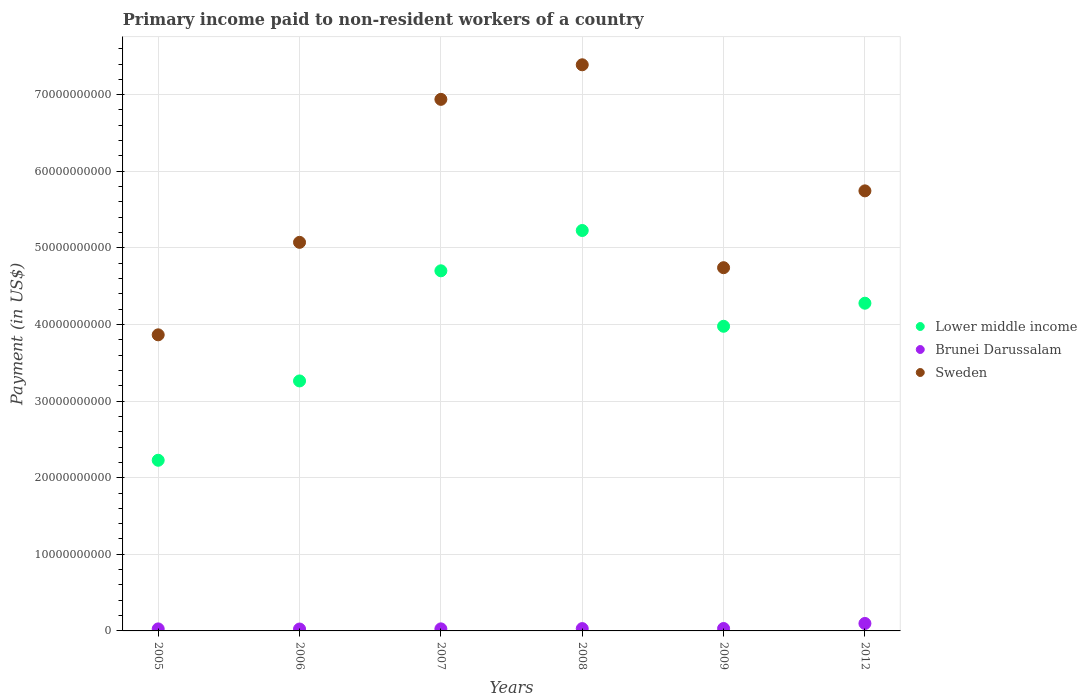How many different coloured dotlines are there?
Ensure brevity in your answer.  3. What is the amount paid to workers in Lower middle income in 2005?
Your response must be concise. 2.23e+1. Across all years, what is the maximum amount paid to workers in Brunei Darussalam?
Provide a short and direct response. 9.74e+08. Across all years, what is the minimum amount paid to workers in Brunei Darussalam?
Make the answer very short. 2.48e+08. What is the total amount paid to workers in Brunei Darussalam in the graph?
Make the answer very short. 2.37e+09. What is the difference between the amount paid to workers in Sweden in 2007 and that in 2012?
Your answer should be compact. 1.19e+1. What is the difference between the amount paid to workers in Brunei Darussalam in 2006 and the amount paid to workers in Lower middle income in 2012?
Give a very brief answer. -4.25e+1. What is the average amount paid to workers in Sweden per year?
Keep it short and to the point. 5.63e+1. In the year 2012, what is the difference between the amount paid to workers in Sweden and amount paid to workers in Brunei Darussalam?
Ensure brevity in your answer.  5.65e+1. In how many years, is the amount paid to workers in Brunei Darussalam greater than 30000000000 US$?
Provide a short and direct response. 0. What is the ratio of the amount paid to workers in Brunei Darussalam in 2007 to that in 2012?
Provide a succinct answer. 0.28. Is the amount paid to workers in Brunei Darussalam in 2005 less than that in 2007?
Provide a short and direct response. Yes. Is the difference between the amount paid to workers in Sweden in 2006 and 2012 greater than the difference between the amount paid to workers in Brunei Darussalam in 2006 and 2012?
Provide a short and direct response. No. What is the difference between the highest and the second highest amount paid to workers in Brunei Darussalam?
Give a very brief answer. 6.58e+08. What is the difference between the highest and the lowest amount paid to workers in Lower middle income?
Keep it short and to the point. 3.00e+1. Is the sum of the amount paid to workers in Brunei Darussalam in 2005 and 2012 greater than the maximum amount paid to workers in Lower middle income across all years?
Give a very brief answer. No. Does the amount paid to workers in Lower middle income monotonically increase over the years?
Provide a succinct answer. No. Is the amount paid to workers in Brunei Darussalam strictly less than the amount paid to workers in Sweden over the years?
Keep it short and to the point. Yes. How many dotlines are there?
Offer a terse response. 3. Does the graph contain any zero values?
Make the answer very short. No. How many legend labels are there?
Offer a very short reply. 3. What is the title of the graph?
Provide a succinct answer. Primary income paid to non-resident workers of a country. Does "Namibia" appear as one of the legend labels in the graph?
Make the answer very short. No. What is the label or title of the Y-axis?
Give a very brief answer. Payment (in US$). What is the Payment (in US$) of Lower middle income in 2005?
Offer a very short reply. 2.23e+1. What is the Payment (in US$) in Brunei Darussalam in 2005?
Offer a very short reply. 2.63e+08. What is the Payment (in US$) in Sweden in 2005?
Keep it short and to the point. 3.87e+1. What is the Payment (in US$) of Lower middle income in 2006?
Ensure brevity in your answer.  3.26e+1. What is the Payment (in US$) in Brunei Darussalam in 2006?
Keep it short and to the point. 2.48e+08. What is the Payment (in US$) of Sweden in 2006?
Offer a very short reply. 5.07e+1. What is the Payment (in US$) of Lower middle income in 2007?
Make the answer very short. 4.70e+1. What is the Payment (in US$) of Brunei Darussalam in 2007?
Provide a short and direct response. 2.68e+08. What is the Payment (in US$) in Sweden in 2007?
Offer a very short reply. 6.94e+1. What is the Payment (in US$) of Lower middle income in 2008?
Your response must be concise. 5.23e+1. What is the Payment (in US$) in Brunei Darussalam in 2008?
Make the answer very short. 3.04e+08. What is the Payment (in US$) in Sweden in 2008?
Keep it short and to the point. 7.39e+1. What is the Payment (in US$) in Lower middle income in 2009?
Keep it short and to the point. 3.98e+1. What is the Payment (in US$) in Brunei Darussalam in 2009?
Keep it short and to the point. 3.16e+08. What is the Payment (in US$) in Sweden in 2009?
Provide a succinct answer. 4.74e+1. What is the Payment (in US$) of Lower middle income in 2012?
Make the answer very short. 4.28e+1. What is the Payment (in US$) in Brunei Darussalam in 2012?
Your answer should be compact. 9.74e+08. What is the Payment (in US$) in Sweden in 2012?
Keep it short and to the point. 5.74e+1. Across all years, what is the maximum Payment (in US$) in Lower middle income?
Give a very brief answer. 5.23e+1. Across all years, what is the maximum Payment (in US$) in Brunei Darussalam?
Provide a short and direct response. 9.74e+08. Across all years, what is the maximum Payment (in US$) of Sweden?
Give a very brief answer. 7.39e+1. Across all years, what is the minimum Payment (in US$) of Lower middle income?
Provide a short and direct response. 2.23e+1. Across all years, what is the minimum Payment (in US$) in Brunei Darussalam?
Your answer should be very brief. 2.48e+08. Across all years, what is the minimum Payment (in US$) of Sweden?
Provide a succinct answer. 3.87e+1. What is the total Payment (in US$) of Lower middle income in the graph?
Ensure brevity in your answer.  2.37e+11. What is the total Payment (in US$) of Brunei Darussalam in the graph?
Ensure brevity in your answer.  2.37e+09. What is the total Payment (in US$) in Sweden in the graph?
Offer a terse response. 3.38e+11. What is the difference between the Payment (in US$) in Lower middle income in 2005 and that in 2006?
Your answer should be compact. -1.04e+1. What is the difference between the Payment (in US$) in Brunei Darussalam in 2005 and that in 2006?
Give a very brief answer. 1.52e+07. What is the difference between the Payment (in US$) in Sweden in 2005 and that in 2006?
Provide a succinct answer. -1.21e+1. What is the difference between the Payment (in US$) in Lower middle income in 2005 and that in 2007?
Your answer should be very brief. -2.47e+1. What is the difference between the Payment (in US$) in Brunei Darussalam in 2005 and that in 2007?
Provide a succinct answer. -5.10e+06. What is the difference between the Payment (in US$) in Sweden in 2005 and that in 2007?
Make the answer very short. -3.07e+1. What is the difference between the Payment (in US$) in Lower middle income in 2005 and that in 2008?
Provide a succinct answer. -3.00e+1. What is the difference between the Payment (in US$) in Brunei Darussalam in 2005 and that in 2008?
Your answer should be compact. -4.04e+07. What is the difference between the Payment (in US$) of Sweden in 2005 and that in 2008?
Offer a very short reply. -3.53e+1. What is the difference between the Payment (in US$) of Lower middle income in 2005 and that in 2009?
Offer a very short reply. -1.75e+1. What is the difference between the Payment (in US$) in Brunei Darussalam in 2005 and that in 2009?
Keep it short and to the point. -5.31e+07. What is the difference between the Payment (in US$) in Sweden in 2005 and that in 2009?
Your response must be concise. -8.76e+09. What is the difference between the Payment (in US$) of Lower middle income in 2005 and that in 2012?
Keep it short and to the point. -2.05e+1. What is the difference between the Payment (in US$) of Brunei Darussalam in 2005 and that in 2012?
Give a very brief answer. -7.11e+08. What is the difference between the Payment (in US$) of Sweden in 2005 and that in 2012?
Your response must be concise. -1.88e+1. What is the difference between the Payment (in US$) in Lower middle income in 2006 and that in 2007?
Your response must be concise. -1.44e+1. What is the difference between the Payment (in US$) in Brunei Darussalam in 2006 and that in 2007?
Your response must be concise. -2.03e+07. What is the difference between the Payment (in US$) of Sweden in 2006 and that in 2007?
Offer a terse response. -1.87e+1. What is the difference between the Payment (in US$) of Lower middle income in 2006 and that in 2008?
Your answer should be compact. -1.96e+1. What is the difference between the Payment (in US$) of Brunei Darussalam in 2006 and that in 2008?
Provide a short and direct response. -5.57e+07. What is the difference between the Payment (in US$) in Sweden in 2006 and that in 2008?
Keep it short and to the point. -2.32e+1. What is the difference between the Payment (in US$) of Lower middle income in 2006 and that in 2009?
Your answer should be very brief. -7.14e+09. What is the difference between the Payment (in US$) in Brunei Darussalam in 2006 and that in 2009?
Offer a terse response. -6.83e+07. What is the difference between the Payment (in US$) in Sweden in 2006 and that in 2009?
Give a very brief answer. 3.31e+09. What is the difference between the Payment (in US$) of Lower middle income in 2006 and that in 2012?
Offer a terse response. -1.01e+1. What is the difference between the Payment (in US$) of Brunei Darussalam in 2006 and that in 2012?
Ensure brevity in your answer.  -7.27e+08. What is the difference between the Payment (in US$) of Sweden in 2006 and that in 2012?
Give a very brief answer. -6.72e+09. What is the difference between the Payment (in US$) of Lower middle income in 2007 and that in 2008?
Ensure brevity in your answer.  -5.26e+09. What is the difference between the Payment (in US$) in Brunei Darussalam in 2007 and that in 2008?
Keep it short and to the point. -3.53e+07. What is the difference between the Payment (in US$) of Sweden in 2007 and that in 2008?
Your answer should be very brief. -4.51e+09. What is the difference between the Payment (in US$) in Lower middle income in 2007 and that in 2009?
Provide a short and direct response. 7.24e+09. What is the difference between the Payment (in US$) of Brunei Darussalam in 2007 and that in 2009?
Provide a short and direct response. -4.80e+07. What is the difference between the Payment (in US$) of Sweden in 2007 and that in 2009?
Keep it short and to the point. 2.20e+1. What is the difference between the Payment (in US$) in Lower middle income in 2007 and that in 2012?
Offer a very short reply. 4.23e+09. What is the difference between the Payment (in US$) of Brunei Darussalam in 2007 and that in 2012?
Provide a short and direct response. -7.06e+08. What is the difference between the Payment (in US$) of Sweden in 2007 and that in 2012?
Offer a terse response. 1.19e+1. What is the difference between the Payment (in US$) of Lower middle income in 2008 and that in 2009?
Offer a very short reply. 1.25e+1. What is the difference between the Payment (in US$) of Brunei Darussalam in 2008 and that in 2009?
Offer a terse response. -1.27e+07. What is the difference between the Payment (in US$) of Sweden in 2008 and that in 2009?
Provide a succinct answer. 2.65e+1. What is the difference between the Payment (in US$) in Lower middle income in 2008 and that in 2012?
Your response must be concise. 9.49e+09. What is the difference between the Payment (in US$) in Brunei Darussalam in 2008 and that in 2012?
Provide a short and direct response. -6.71e+08. What is the difference between the Payment (in US$) of Sweden in 2008 and that in 2012?
Offer a terse response. 1.65e+1. What is the difference between the Payment (in US$) in Lower middle income in 2009 and that in 2012?
Your answer should be very brief. -3.01e+09. What is the difference between the Payment (in US$) in Brunei Darussalam in 2009 and that in 2012?
Offer a terse response. -6.58e+08. What is the difference between the Payment (in US$) of Sweden in 2009 and that in 2012?
Your answer should be very brief. -1.00e+1. What is the difference between the Payment (in US$) of Lower middle income in 2005 and the Payment (in US$) of Brunei Darussalam in 2006?
Your response must be concise. 2.20e+1. What is the difference between the Payment (in US$) of Lower middle income in 2005 and the Payment (in US$) of Sweden in 2006?
Provide a short and direct response. -2.84e+1. What is the difference between the Payment (in US$) of Brunei Darussalam in 2005 and the Payment (in US$) of Sweden in 2006?
Your answer should be compact. -5.05e+1. What is the difference between the Payment (in US$) of Lower middle income in 2005 and the Payment (in US$) of Brunei Darussalam in 2007?
Provide a short and direct response. 2.20e+1. What is the difference between the Payment (in US$) in Lower middle income in 2005 and the Payment (in US$) in Sweden in 2007?
Offer a terse response. -4.71e+1. What is the difference between the Payment (in US$) of Brunei Darussalam in 2005 and the Payment (in US$) of Sweden in 2007?
Provide a succinct answer. -6.91e+1. What is the difference between the Payment (in US$) of Lower middle income in 2005 and the Payment (in US$) of Brunei Darussalam in 2008?
Ensure brevity in your answer.  2.20e+1. What is the difference between the Payment (in US$) in Lower middle income in 2005 and the Payment (in US$) in Sweden in 2008?
Your answer should be compact. -5.16e+1. What is the difference between the Payment (in US$) of Brunei Darussalam in 2005 and the Payment (in US$) of Sweden in 2008?
Give a very brief answer. -7.36e+1. What is the difference between the Payment (in US$) of Lower middle income in 2005 and the Payment (in US$) of Brunei Darussalam in 2009?
Provide a short and direct response. 2.20e+1. What is the difference between the Payment (in US$) in Lower middle income in 2005 and the Payment (in US$) in Sweden in 2009?
Offer a terse response. -2.51e+1. What is the difference between the Payment (in US$) of Brunei Darussalam in 2005 and the Payment (in US$) of Sweden in 2009?
Offer a very short reply. -4.72e+1. What is the difference between the Payment (in US$) of Lower middle income in 2005 and the Payment (in US$) of Brunei Darussalam in 2012?
Provide a succinct answer. 2.13e+1. What is the difference between the Payment (in US$) in Lower middle income in 2005 and the Payment (in US$) in Sweden in 2012?
Provide a succinct answer. -3.52e+1. What is the difference between the Payment (in US$) of Brunei Darussalam in 2005 and the Payment (in US$) of Sweden in 2012?
Your answer should be very brief. -5.72e+1. What is the difference between the Payment (in US$) in Lower middle income in 2006 and the Payment (in US$) in Brunei Darussalam in 2007?
Provide a short and direct response. 3.24e+1. What is the difference between the Payment (in US$) of Lower middle income in 2006 and the Payment (in US$) of Sweden in 2007?
Offer a very short reply. -3.68e+1. What is the difference between the Payment (in US$) in Brunei Darussalam in 2006 and the Payment (in US$) in Sweden in 2007?
Offer a very short reply. -6.91e+1. What is the difference between the Payment (in US$) in Lower middle income in 2006 and the Payment (in US$) in Brunei Darussalam in 2008?
Offer a very short reply. 3.23e+1. What is the difference between the Payment (in US$) in Lower middle income in 2006 and the Payment (in US$) in Sweden in 2008?
Give a very brief answer. -4.13e+1. What is the difference between the Payment (in US$) in Brunei Darussalam in 2006 and the Payment (in US$) in Sweden in 2008?
Offer a very short reply. -7.37e+1. What is the difference between the Payment (in US$) of Lower middle income in 2006 and the Payment (in US$) of Brunei Darussalam in 2009?
Your response must be concise. 3.23e+1. What is the difference between the Payment (in US$) in Lower middle income in 2006 and the Payment (in US$) in Sweden in 2009?
Ensure brevity in your answer.  -1.48e+1. What is the difference between the Payment (in US$) in Brunei Darussalam in 2006 and the Payment (in US$) in Sweden in 2009?
Offer a very short reply. -4.72e+1. What is the difference between the Payment (in US$) in Lower middle income in 2006 and the Payment (in US$) in Brunei Darussalam in 2012?
Provide a short and direct response. 3.17e+1. What is the difference between the Payment (in US$) of Lower middle income in 2006 and the Payment (in US$) of Sweden in 2012?
Ensure brevity in your answer.  -2.48e+1. What is the difference between the Payment (in US$) in Brunei Darussalam in 2006 and the Payment (in US$) in Sweden in 2012?
Provide a succinct answer. -5.72e+1. What is the difference between the Payment (in US$) of Lower middle income in 2007 and the Payment (in US$) of Brunei Darussalam in 2008?
Keep it short and to the point. 4.67e+1. What is the difference between the Payment (in US$) of Lower middle income in 2007 and the Payment (in US$) of Sweden in 2008?
Your response must be concise. -2.69e+1. What is the difference between the Payment (in US$) of Brunei Darussalam in 2007 and the Payment (in US$) of Sweden in 2008?
Offer a very short reply. -7.36e+1. What is the difference between the Payment (in US$) of Lower middle income in 2007 and the Payment (in US$) of Brunei Darussalam in 2009?
Keep it short and to the point. 4.67e+1. What is the difference between the Payment (in US$) of Lower middle income in 2007 and the Payment (in US$) of Sweden in 2009?
Give a very brief answer. -4.05e+08. What is the difference between the Payment (in US$) of Brunei Darussalam in 2007 and the Payment (in US$) of Sweden in 2009?
Your answer should be very brief. -4.71e+1. What is the difference between the Payment (in US$) of Lower middle income in 2007 and the Payment (in US$) of Brunei Darussalam in 2012?
Provide a succinct answer. 4.60e+1. What is the difference between the Payment (in US$) of Lower middle income in 2007 and the Payment (in US$) of Sweden in 2012?
Give a very brief answer. -1.04e+1. What is the difference between the Payment (in US$) of Brunei Darussalam in 2007 and the Payment (in US$) of Sweden in 2012?
Offer a terse response. -5.72e+1. What is the difference between the Payment (in US$) in Lower middle income in 2008 and the Payment (in US$) in Brunei Darussalam in 2009?
Keep it short and to the point. 5.20e+1. What is the difference between the Payment (in US$) of Lower middle income in 2008 and the Payment (in US$) of Sweden in 2009?
Provide a succinct answer. 4.86e+09. What is the difference between the Payment (in US$) in Brunei Darussalam in 2008 and the Payment (in US$) in Sweden in 2009?
Offer a very short reply. -4.71e+1. What is the difference between the Payment (in US$) in Lower middle income in 2008 and the Payment (in US$) in Brunei Darussalam in 2012?
Ensure brevity in your answer.  5.13e+1. What is the difference between the Payment (in US$) of Lower middle income in 2008 and the Payment (in US$) of Sweden in 2012?
Make the answer very short. -5.17e+09. What is the difference between the Payment (in US$) of Brunei Darussalam in 2008 and the Payment (in US$) of Sweden in 2012?
Your answer should be very brief. -5.71e+1. What is the difference between the Payment (in US$) in Lower middle income in 2009 and the Payment (in US$) in Brunei Darussalam in 2012?
Your answer should be compact. 3.88e+1. What is the difference between the Payment (in US$) of Lower middle income in 2009 and the Payment (in US$) of Sweden in 2012?
Keep it short and to the point. -1.77e+1. What is the difference between the Payment (in US$) in Brunei Darussalam in 2009 and the Payment (in US$) in Sweden in 2012?
Your answer should be very brief. -5.71e+1. What is the average Payment (in US$) in Lower middle income per year?
Your response must be concise. 3.95e+1. What is the average Payment (in US$) of Brunei Darussalam per year?
Give a very brief answer. 3.96e+08. What is the average Payment (in US$) of Sweden per year?
Ensure brevity in your answer.  5.63e+1. In the year 2005, what is the difference between the Payment (in US$) of Lower middle income and Payment (in US$) of Brunei Darussalam?
Make the answer very short. 2.20e+1. In the year 2005, what is the difference between the Payment (in US$) of Lower middle income and Payment (in US$) of Sweden?
Provide a short and direct response. -1.64e+1. In the year 2005, what is the difference between the Payment (in US$) in Brunei Darussalam and Payment (in US$) in Sweden?
Provide a short and direct response. -3.84e+1. In the year 2006, what is the difference between the Payment (in US$) in Lower middle income and Payment (in US$) in Brunei Darussalam?
Your response must be concise. 3.24e+1. In the year 2006, what is the difference between the Payment (in US$) in Lower middle income and Payment (in US$) in Sweden?
Your answer should be compact. -1.81e+1. In the year 2006, what is the difference between the Payment (in US$) of Brunei Darussalam and Payment (in US$) of Sweden?
Your response must be concise. -5.05e+1. In the year 2007, what is the difference between the Payment (in US$) of Lower middle income and Payment (in US$) of Brunei Darussalam?
Offer a very short reply. 4.67e+1. In the year 2007, what is the difference between the Payment (in US$) in Lower middle income and Payment (in US$) in Sweden?
Provide a short and direct response. -2.24e+1. In the year 2007, what is the difference between the Payment (in US$) in Brunei Darussalam and Payment (in US$) in Sweden?
Offer a terse response. -6.91e+1. In the year 2008, what is the difference between the Payment (in US$) in Lower middle income and Payment (in US$) in Brunei Darussalam?
Give a very brief answer. 5.20e+1. In the year 2008, what is the difference between the Payment (in US$) of Lower middle income and Payment (in US$) of Sweden?
Provide a short and direct response. -2.16e+1. In the year 2008, what is the difference between the Payment (in US$) of Brunei Darussalam and Payment (in US$) of Sweden?
Your answer should be very brief. -7.36e+1. In the year 2009, what is the difference between the Payment (in US$) of Lower middle income and Payment (in US$) of Brunei Darussalam?
Your answer should be very brief. 3.95e+1. In the year 2009, what is the difference between the Payment (in US$) in Lower middle income and Payment (in US$) in Sweden?
Your answer should be compact. -7.65e+09. In the year 2009, what is the difference between the Payment (in US$) of Brunei Darussalam and Payment (in US$) of Sweden?
Provide a short and direct response. -4.71e+1. In the year 2012, what is the difference between the Payment (in US$) of Lower middle income and Payment (in US$) of Brunei Darussalam?
Your answer should be very brief. 4.18e+1. In the year 2012, what is the difference between the Payment (in US$) of Lower middle income and Payment (in US$) of Sweden?
Offer a terse response. -1.47e+1. In the year 2012, what is the difference between the Payment (in US$) of Brunei Darussalam and Payment (in US$) of Sweden?
Provide a short and direct response. -5.65e+1. What is the ratio of the Payment (in US$) of Lower middle income in 2005 to that in 2006?
Give a very brief answer. 0.68. What is the ratio of the Payment (in US$) in Brunei Darussalam in 2005 to that in 2006?
Your answer should be compact. 1.06. What is the ratio of the Payment (in US$) in Sweden in 2005 to that in 2006?
Your response must be concise. 0.76. What is the ratio of the Payment (in US$) in Lower middle income in 2005 to that in 2007?
Your answer should be compact. 0.47. What is the ratio of the Payment (in US$) in Sweden in 2005 to that in 2007?
Your answer should be compact. 0.56. What is the ratio of the Payment (in US$) in Lower middle income in 2005 to that in 2008?
Offer a very short reply. 0.43. What is the ratio of the Payment (in US$) in Brunei Darussalam in 2005 to that in 2008?
Your answer should be very brief. 0.87. What is the ratio of the Payment (in US$) in Sweden in 2005 to that in 2008?
Provide a succinct answer. 0.52. What is the ratio of the Payment (in US$) of Lower middle income in 2005 to that in 2009?
Keep it short and to the point. 0.56. What is the ratio of the Payment (in US$) of Brunei Darussalam in 2005 to that in 2009?
Offer a terse response. 0.83. What is the ratio of the Payment (in US$) of Sweden in 2005 to that in 2009?
Offer a very short reply. 0.82. What is the ratio of the Payment (in US$) in Lower middle income in 2005 to that in 2012?
Your answer should be compact. 0.52. What is the ratio of the Payment (in US$) of Brunei Darussalam in 2005 to that in 2012?
Offer a very short reply. 0.27. What is the ratio of the Payment (in US$) in Sweden in 2005 to that in 2012?
Your response must be concise. 0.67. What is the ratio of the Payment (in US$) of Lower middle income in 2006 to that in 2007?
Provide a short and direct response. 0.69. What is the ratio of the Payment (in US$) of Brunei Darussalam in 2006 to that in 2007?
Give a very brief answer. 0.92. What is the ratio of the Payment (in US$) of Sweden in 2006 to that in 2007?
Make the answer very short. 0.73. What is the ratio of the Payment (in US$) of Lower middle income in 2006 to that in 2008?
Give a very brief answer. 0.62. What is the ratio of the Payment (in US$) in Brunei Darussalam in 2006 to that in 2008?
Offer a very short reply. 0.82. What is the ratio of the Payment (in US$) of Sweden in 2006 to that in 2008?
Your answer should be compact. 0.69. What is the ratio of the Payment (in US$) of Lower middle income in 2006 to that in 2009?
Offer a terse response. 0.82. What is the ratio of the Payment (in US$) in Brunei Darussalam in 2006 to that in 2009?
Give a very brief answer. 0.78. What is the ratio of the Payment (in US$) in Sweden in 2006 to that in 2009?
Offer a very short reply. 1.07. What is the ratio of the Payment (in US$) of Lower middle income in 2006 to that in 2012?
Your response must be concise. 0.76. What is the ratio of the Payment (in US$) of Brunei Darussalam in 2006 to that in 2012?
Make the answer very short. 0.25. What is the ratio of the Payment (in US$) in Sweden in 2006 to that in 2012?
Your response must be concise. 0.88. What is the ratio of the Payment (in US$) of Lower middle income in 2007 to that in 2008?
Keep it short and to the point. 0.9. What is the ratio of the Payment (in US$) of Brunei Darussalam in 2007 to that in 2008?
Your response must be concise. 0.88. What is the ratio of the Payment (in US$) in Sweden in 2007 to that in 2008?
Give a very brief answer. 0.94. What is the ratio of the Payment (in US$) in Lower middle income in 2007 to that in 2009?
Keep it short and to the point. 1.18. What is the ratio of the Payment (in US$) of Brunei Darussalam in 2007 to that in 2009?
Keep it short and to the point. 0.85. What is the ratio of the Payment (in US$) in Sweden in 2007 to that in 2009?
Provide a short and direct response. 1.46. What is the ratio of the Payment (in US$) of Lower middle income in 2007 to that in 2012?
Your answer should be very brief. 1.1. What is the ratio of the Payment (in US$) of Brunei Darussalam in 2007 to that in 2012?
Provide a short and direct response. 0.28. What is the ratio of the Payment (in US$) of Sweden in 2007 to that in 2012?
Offer a very short reply. 1.21. What is the ratio of the Payment (in US$) in Lower middle income in 2008 to that in 2009?
Ensure brevity in your answer.  1.31. What is the ratio of the Payment (in US$) of Brunei Darussalam in 2008 to that in 2009?
Offer a terse response. 0.96. What is the ratio of the Payment (in US$) of Sweden in 2008 to that in 2009?
Your answer should be compact. 1.56. What is the ratio of the Payment (in US$) of Lower middle income in 2008 to that in 2012?
Provide a succinct answer. 1.22. What is the ratio of the Payment (in US$) in Brunei Darussalam in 2008 to that in 2012?
Your answer should be very brief. 0.31. What is the ratio of the Payment (in US$) of Sweden in 2008 to that in 2012?
Provide a short and direct response. 1.29. What is the ratio of the Payment (in US$) of Lower middle income in 2009 to that in 2012?
Your answer should be very brief. 0.93. What is the ratio of the Payment (in US$) of Brunei Darussalam in 2009 to that in 2012?
Your answer should be very brief. 0.32. What is the ratio of the Payment (in US$) of Sweden in 2009 to that in 2012?
Offer a terse response. 0.83. What is the difference between the highest and the second highest Payment (in US$) of Lower middle income?
Your response must be concise. 5.26e+09. What is the difference between the highest and the second highest Payment (in US$) in Brunei Darussalam?
Offer a very short reply. 6.58e+08. What is the difference between the highest and the second highest Payment (in US$) in Sweden?
Provide a succinct answer. 4.51e+09. What is the difference between the highest and the lowest Payment (in US$) in Lower middle income?
Offer a very short reply. 3.00e+1. What is the difference between the highest and the lowest Payment (in US$) of Brunei Darussalam?
Your answer should be compact. 7.27e+08. What is the difference between the highest and the lowest Payment (in US$) of Sweden?
Ensure brevity in your answer.  3.53e+1. 